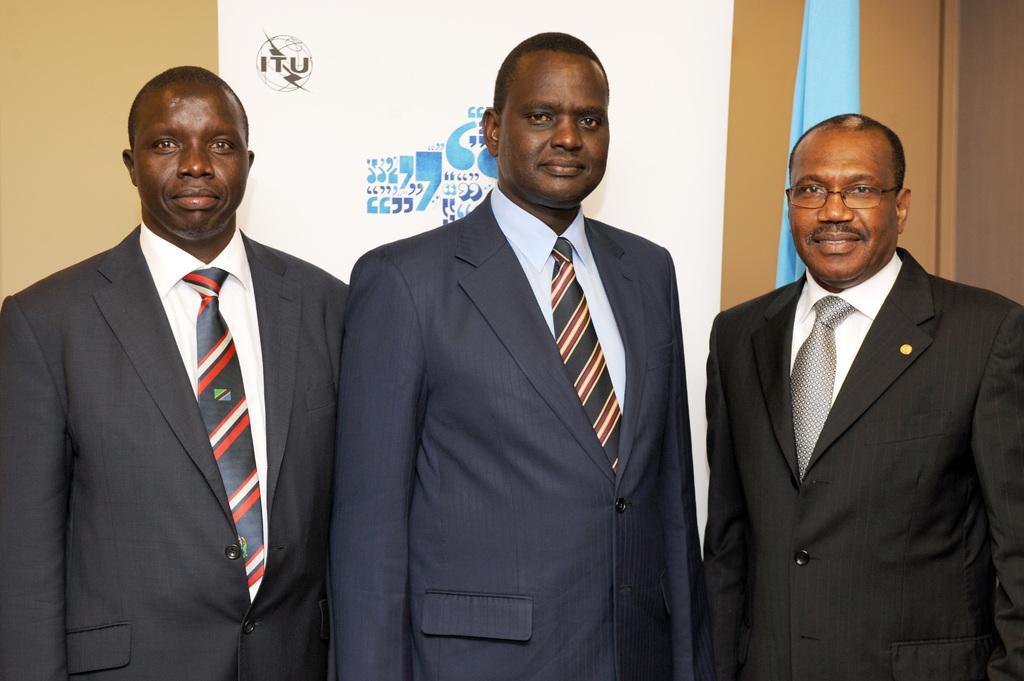Could you give a brief overview of what you see in this image? In this image there are three persons standing. They are wearing suit and tie. Right side person is wearing spectacles. Behind them there is a banner attached to the wall. Right side there is a cloth. 